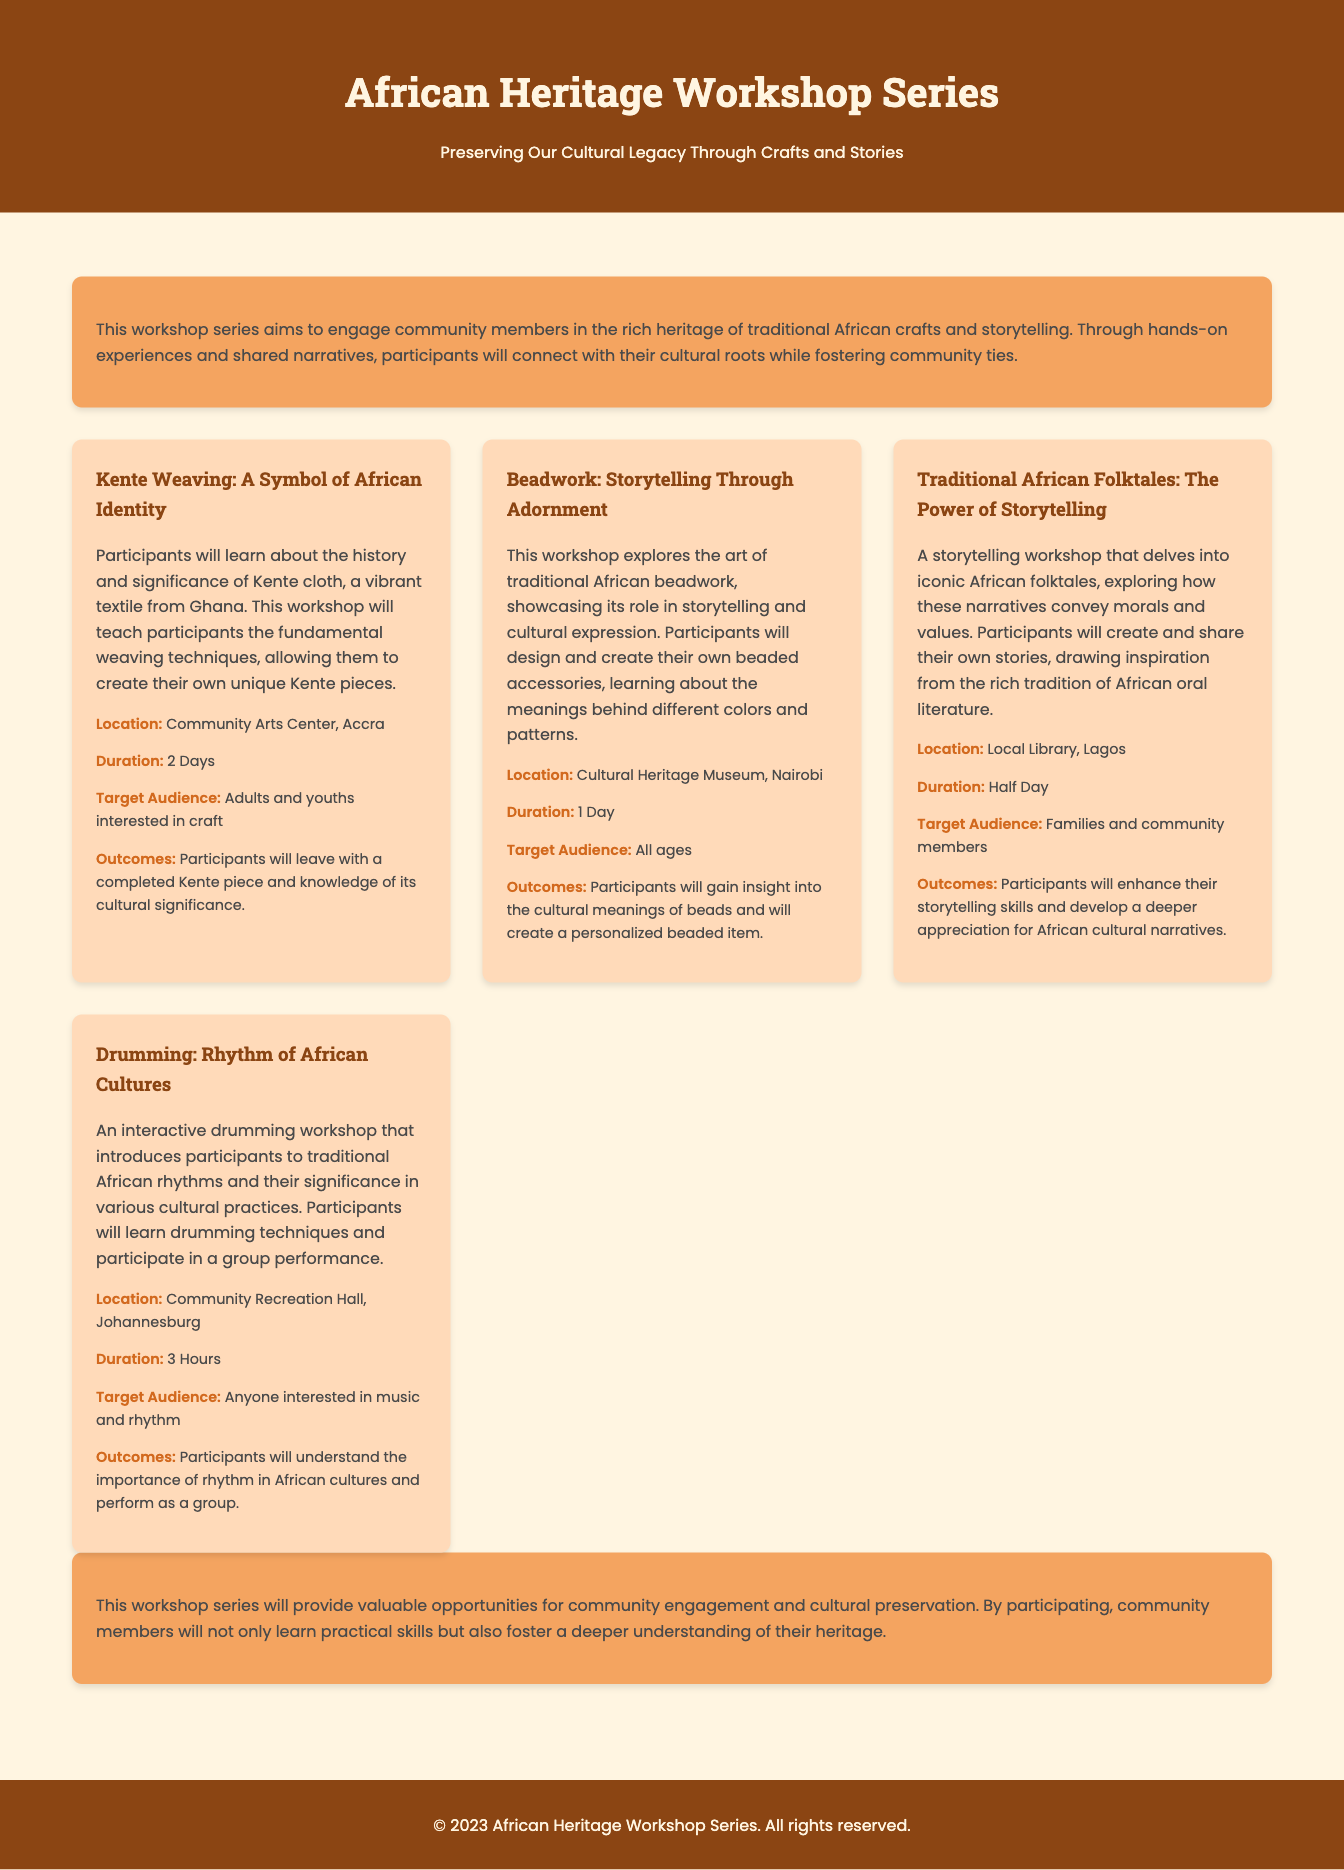What is the title of the workshop series? The title of the workshop series is stated in the header of the document.
Answer: African Heritage Workshop Series How many days is the Kente Weaving workshop? The duration of the Kente Weaving workshop is mentioned in the details provided.
Answer: 2 Days Where is the Beadwork workshop located? The location for the Beadwork workshop is explicitly mentioned in the workshop details.
Answer: Cultural Heritage Museum, Nairobi Who is the target audience for the Traditional African Folktales workshop? The target audience for the workshop is specified in its details.
Answer: Families and community members What will participants create in the Beadwork workshop? The outcomes of the Beadwork workshop include the specific item participants will create, as stated in the details.
Answer: A personalized beaded item Why is the Drumming workshop significant? The workshop's significance is described by its relation to cultural practices and engagement.
Answer: Introduces traditional African rhythms How many workshops are listed in the document? The number of workshops is calculated based on the workshop cards displayed in the document.
Answer: 4 What is the conclusion of the workshop series about? The conclusion summarizes the goals and benefits of the workshop series for the community.
Answer: Community engagement and cultural preservation What is the main focus of the workshop series? The introduction clearly defines the primary aim of the workshop series.
Answer: Traditional African crafts and storytelling 